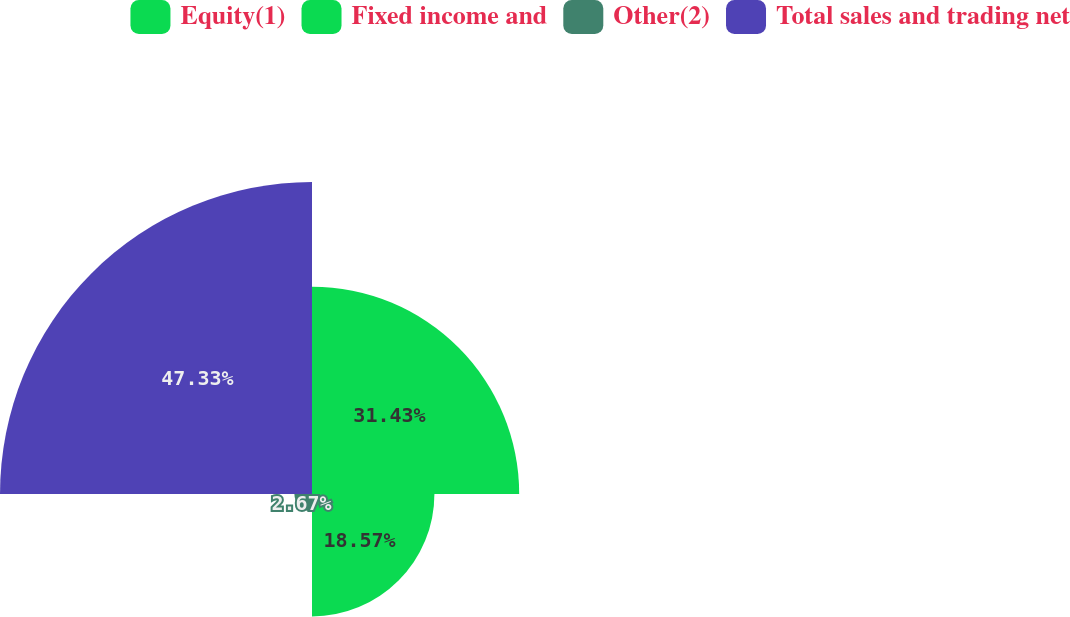Convert chart. <chart><loc_0><loc_0><loc_500><loc_500><pie_chart><fcel>Equity(1)<fcel>Fixed income and<fcel>Other(2)<fcel>Total sales and trading net<nl><fcel>31.43%<fcel>18.57%<fcel>2.67%<fcel>47.33%<nl></chart> 